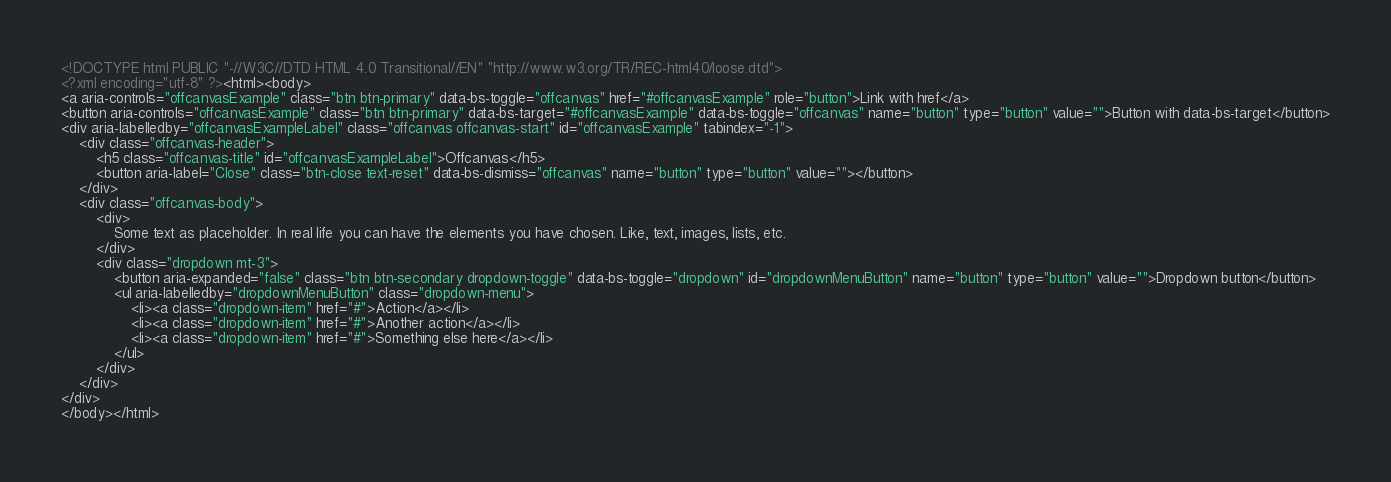<code> <loc_0><loc_0><loc_500><loc_500><_HTML_><!DOCTYPE html PUBLIC "-//W3C//DTD HTML 4.0 Transitional//EN" "http://www.w3.org/TR/REC-html40/loose.dtd">
<?xml encoding="utf-8" ?><html><body>
<a aria-controls="offcanvasExample" class="btn btn-primary" data-bs-toggle="offcanvas" href="#offcanvasExample" role="button">Link with href</a>
<button aria-controls="offcanvasExample" class="btn btn-primary" data-bs-target="#offcanvasExample" data-bs-toggle="offcanvas" name="button" type="button" value="">Button with data-bs-target</button>
<div aria-labelledby="offcanvasExampleLabel" class="offcanvas offcanvas-start" id="offcanvasExample" tabindex="-1">
    <div class="offcanvas-header">
        <h5 class="offcanvas-title" id="offcanvasExampleLabel">Offcanvas</h5>
        <button aria-label="Close" class="btn-close text-reset" data-bs-dismiss="offcanvas" name="button" type="button" value=""></button>
    </div>
    <div class="offcanvas-body">
        <div>
            Some text as placeholder. In real life you can have the elements you have chosen. Like, text, images, lists, etc.
        </div>
        <div class="dropdown mt-3">
            <button aria-expanded="false" class="btn btn-secondary dropdown-toggle" data-bs-toggle="dropdown" id="dropdownMenuButton" name="button" type="button" value="">Dropdown button</button>
            <ul aria-labelledby="dropdownMenuButton" class="dropdown-menu">
                <li><a class="dropdown-item" href="#">Action</a></li>
                <li><a class="dropdown-item" href="#">Another action</a></li>
                <li><a class="dropdown-item" href="#">Something else here</a></li>
            </ul>
        </div>
    </div>
</div>
</body></html>
</code> 